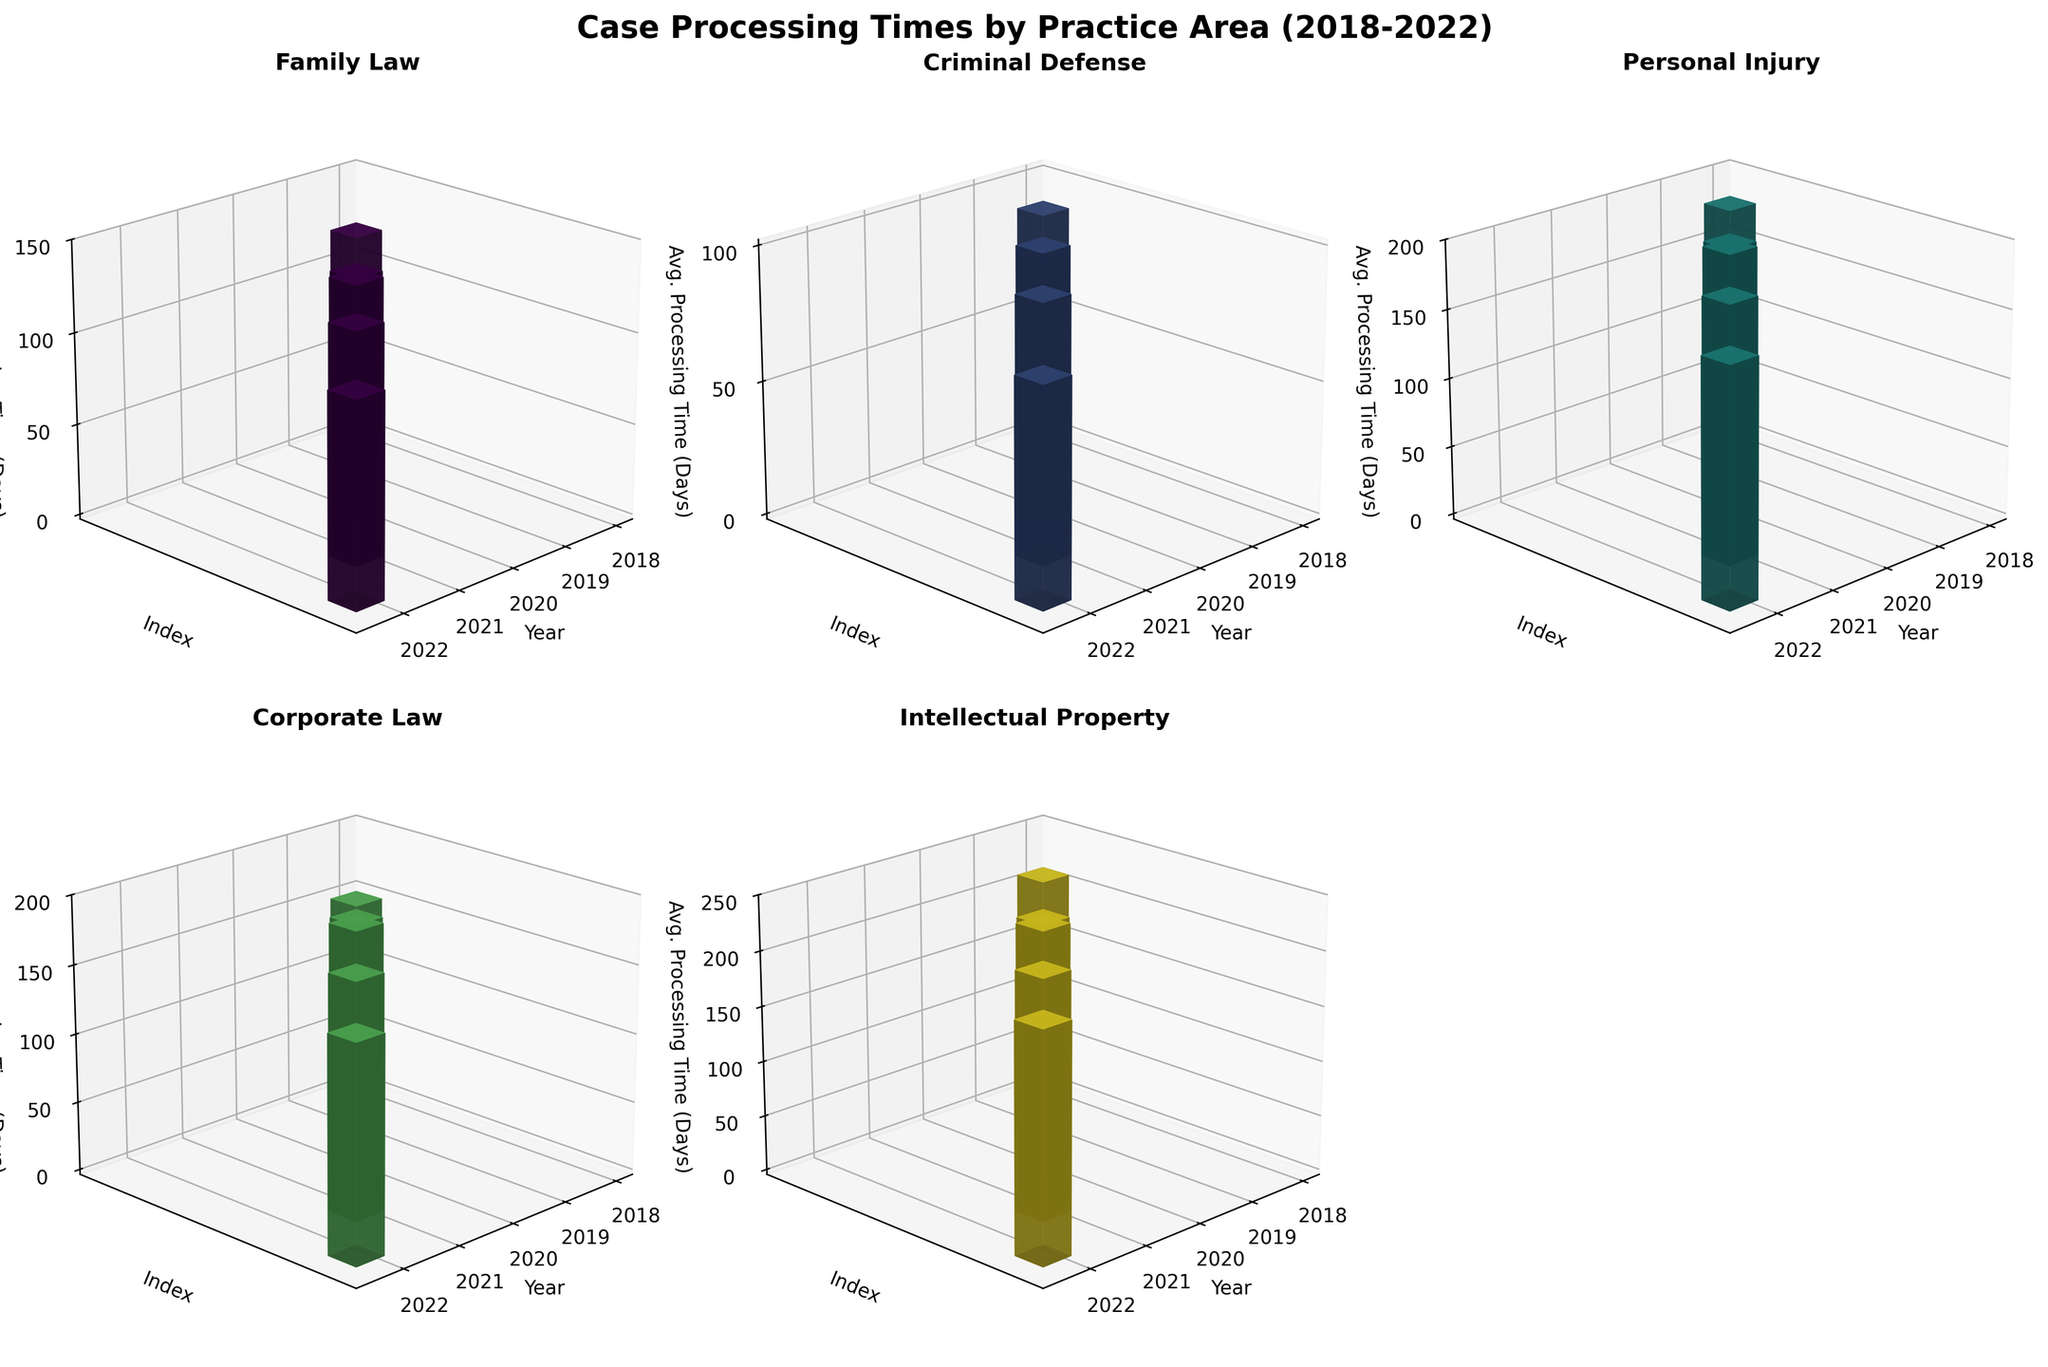What is the title of the figure? The title of the figure is displayed at the top. It reads "Case Processing Times by Practice Area (2018-2022)".
Answer: Case Processing Times by Practice Area (2018-2022) How many practice areas are compared in the figure? The figure contains six subplots, each corresponding to a practice area.
Answer: Five Which practice area had the highest average processing time in 2022? In the subplot for 2022, the highest bar represents Intellectual Property. Viewing this area's subplot shows it had the highest processing time.
Answer: Intellectual Property Did the average processing time for Criminal Defense cases increase or decrease between 2018 and 2022? By examining the heights of the bars for Criminal Defense for the years 2018 and 2022, we see a decrease in the bar height, indicating a decrease in processing time.
Answer: Decrease Which practice area shows the most consistent processing times across the years? Consistency can be observed by minimal changes in bar heights over the years. Corporate Law shows relatively stable bar heights compared to other practice areas.
Answer: Corporate Law What is the range of average processing times for Family Law across the five years? By looking at the subplot for Family Law, the highest bar is for 2020 (130 days) and the lowest is for 2022 (110 days). The range is the difference between these values.
Answer: 20 days Which two practice areas had an increase in average processing time from 2019 to 2020? By comparing the bars for 2019 and 2020 in each subplot, Family Law and Corporate Law show an increase in bar height from 2019 to 2020.
Answer: Family Law and Corporate Law What is the smallest average processing time recorded in the figure, and which practice area and year does it correspond to? The smallest bar across all subplots corresponds to Criminal Defense in the year 2022 at 80 days.
Answer: 80 days, Criminal Defense in 2022 Considering Personal Injury cases, in which year was there the largest decrease in average processing time compared to the previous year? By examining the subplot for Personal Injury, we see the largest drop in bar height from 2021 (185 days) to 2022 (170 days), which is a 15-day decrease.
Answer: 2022 Which practice area shows a clear trend of increasing processing times over the years? Intellectual Property shows increasing heights in bars consistently from 2018 to 2020, indicating a trend of growing processing times.
Answer: Intellectual Property 